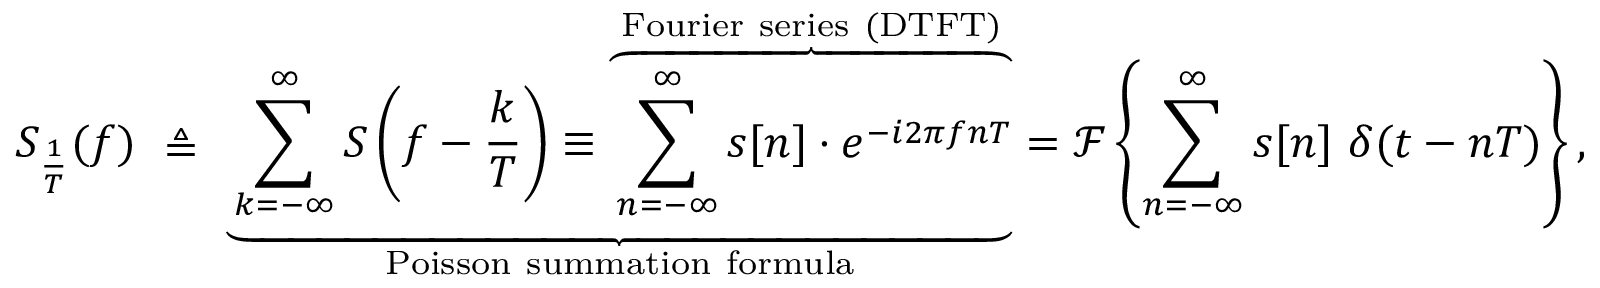<formula> <loc_0><loc_0><loc_500><loc_500>S _ { \frac { 1 } { T } } ( f ) \ \triangle q \ \underbrace { \sum _ { k = - \infty } ^ { \infty } S \left ( f - { \frac { k } { T } } \right ) \equiv \overbrace { \sum _ { n = - \infty } ^ { \infty } s [ n ] \cdot e ^ { - i 2 \pi f n T } } ^ { F o u r i e r s e r i e s ( D T F T ) } } _ { P o i s s o n s u m m a t i o n f o r m u l a } = { \mathcal { F } } \left \{ \sum _ { n = - \infty } ^ { \infty } s [ n ] \ \delta ( t - n T ) \right \} ,</formula> 